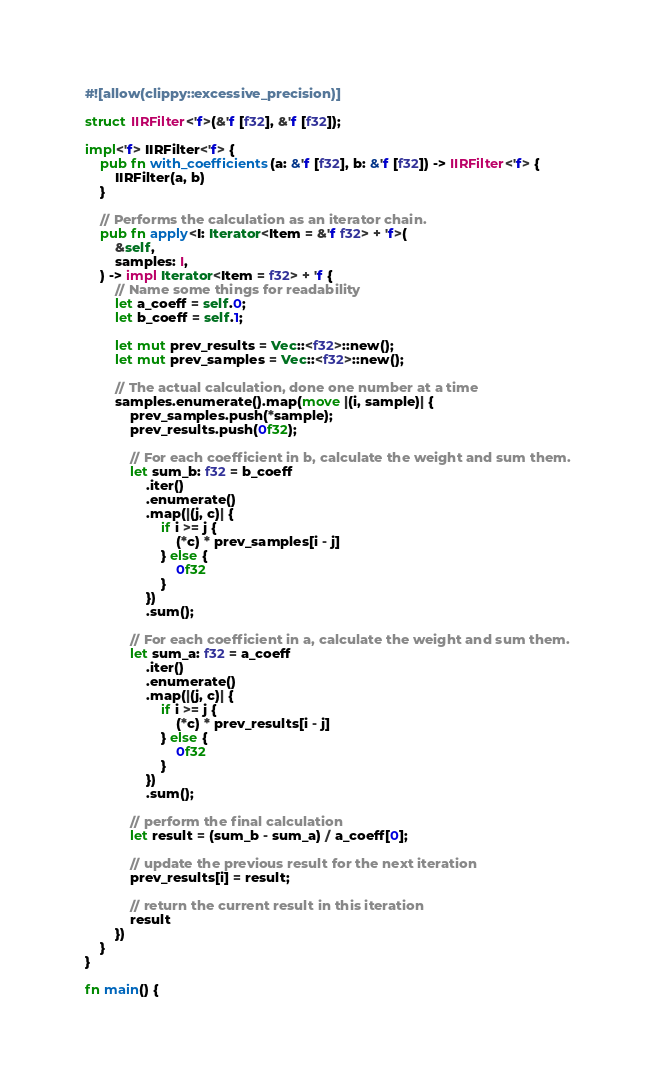Convert code to text. <code><loc_0><loc_0><loc_500><loc_500><_Rust_>#![allow(clippy::excessive_precision)]

struct IIRFilter<'f>(&'f [f32], &'f [f32]);

impl<'f> IIRFilter<'f> {
    pub fn with_coefficients(a: &'f [f32], b: &'f [f32]) -> IIRFilter<'f> {
        IIRFilter(a, b)
    }

    // Performs the calculation as an iterator chain.
    pub fn apply<I: Iterator<Item = &'f f32> + 'f>(
        &self,
        samples: I,
    ) -> impl Iterator<Item = f32> + 'f {
        // Name some things for readability
        let a_coeff = self.0;
        let b_coeff = self.1;

        let mut prev_results = Vec::<f32>::new();
        let mut prev_samples = Vec::<f32>::new();

        // The actual calculation, done one number at a time
        samples.enumerate().map(move |(i, sample)| {
            prev_samples.push(*sample);
            prev_results.push(0f32);

            // For each coefficient in b, calculate the weight and sum them.
            let sum_b: f32 = b_coeff
                .iter()
                .enumerate()
                .map(|(j, c)| {
                    if i >= j {
                        (*c) * prev_samples[i - j]
                    } else {
                        0f32
                    }
                })
                .sum();

            // For each coefficient in a, calculate the weight and sum them.
            let sum_a: f32 = a_coeff
                .iter()
                .enumerate()
                .map(|(j, c)| {
                    if i >= j {
                        (*c) * prev_results[i - j]
                    } else {
                        0f32
                    }
                })
                .sum();

            // perform the final calculation
            let result = (sum_b - sum_a) / a_coeff[0];

            // update the previous result for the next iteration
            prev_results[i] = result;

            // return the current result in this iteration
            result
        })
    }
}

fn main() {</code> 